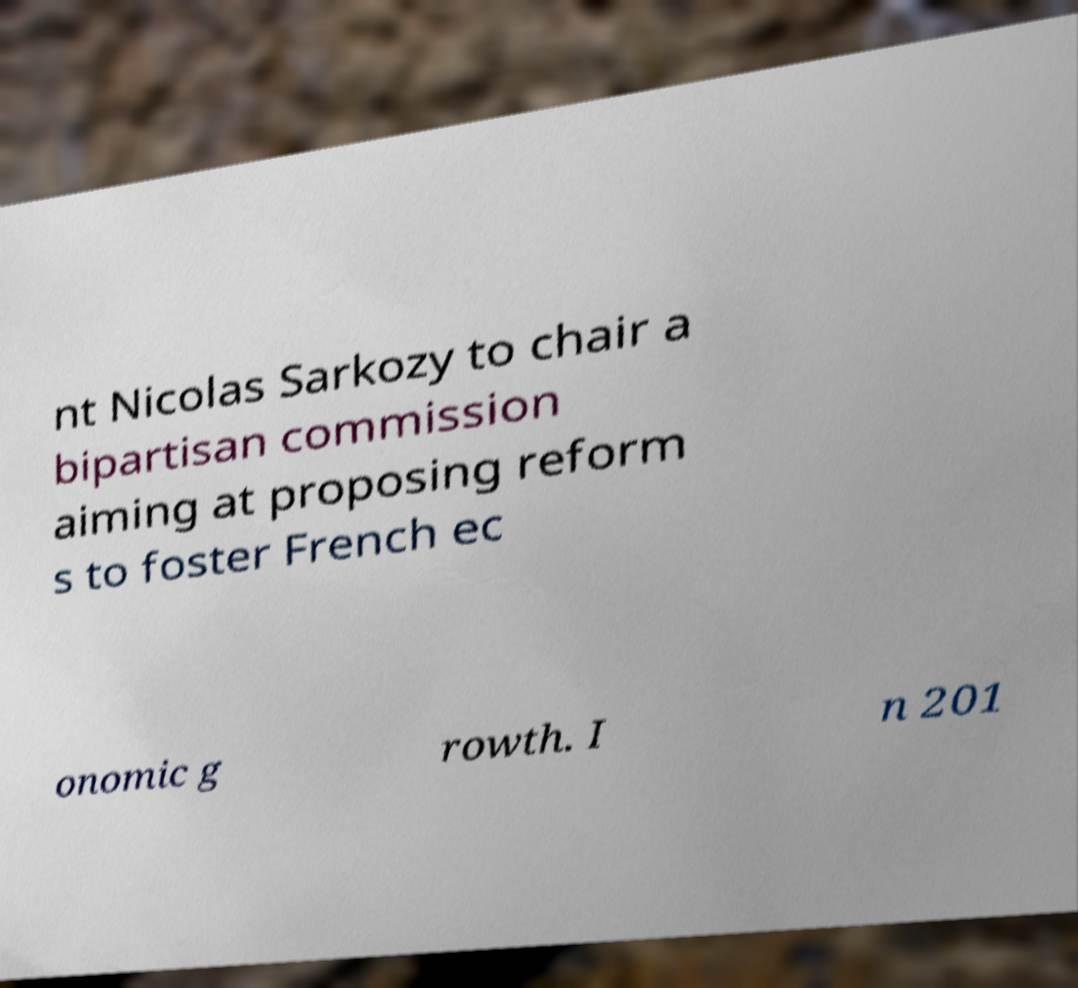Can you accurately transcribe the text from the provided image for me? nt Nicolas Sarkozy to chair a bipartisan commission aiming at proposing reform s to foster French ec onomic g rowth. I n 201 